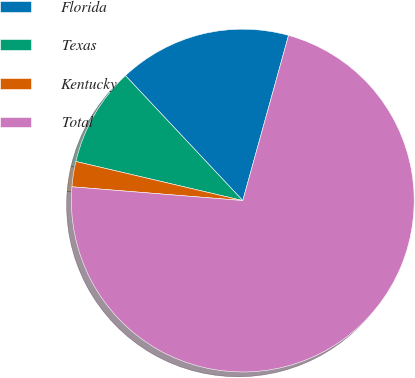Convert chart. <chart><loc_0><loc_0><loc_500><loc_500><pie_chart><fcel>Florida<fcel>Texas<fcel>Kentucky<fcel>Total<nl><fcel>16.3%<fcel>9.34%<fcel>2.38%<fcel>71.97%<nl></chart> 